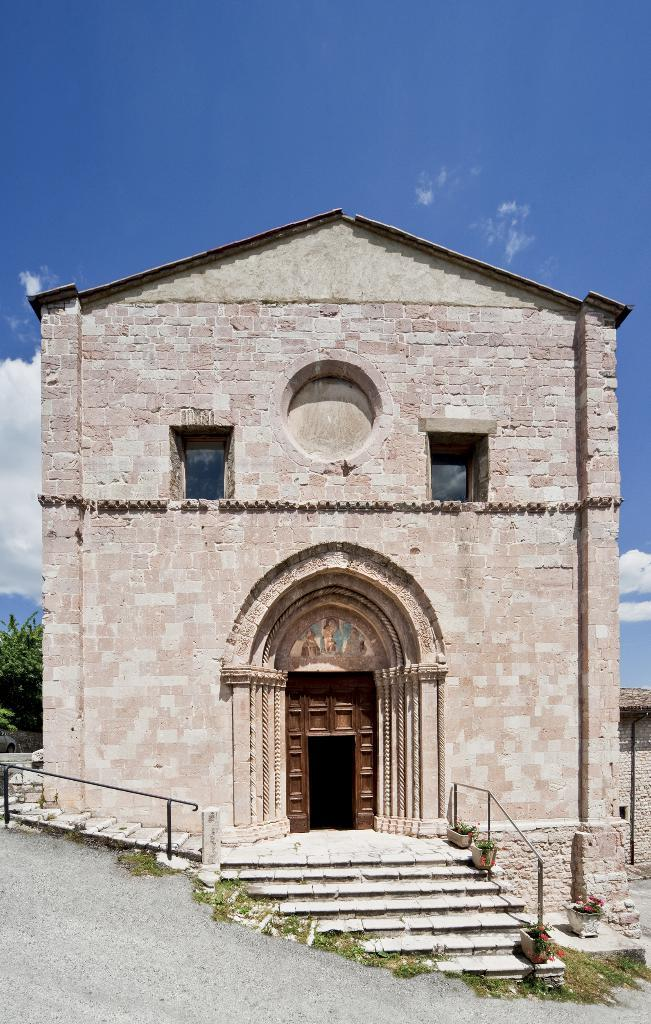What type of structure is present in the image? There is a building in the image. What features can be observed on the building? The building has windows and stairs. Are there any plants visible in the image? Yes, there are plants in pots in the image. What safety feature is present in the image? There are railings in the image. What type of vegetation is visible in the image? There is a tree in the image. What can be seen in the background of the image? Clouds and the sky are visible in the background. What type of bait is being used to catch fish in the image? There is no fishing or bait present in the image; it features a building with various features and objects. What part of the building is made of jeans? There is no mention of jeans or any part of the building being made of them in the image. 